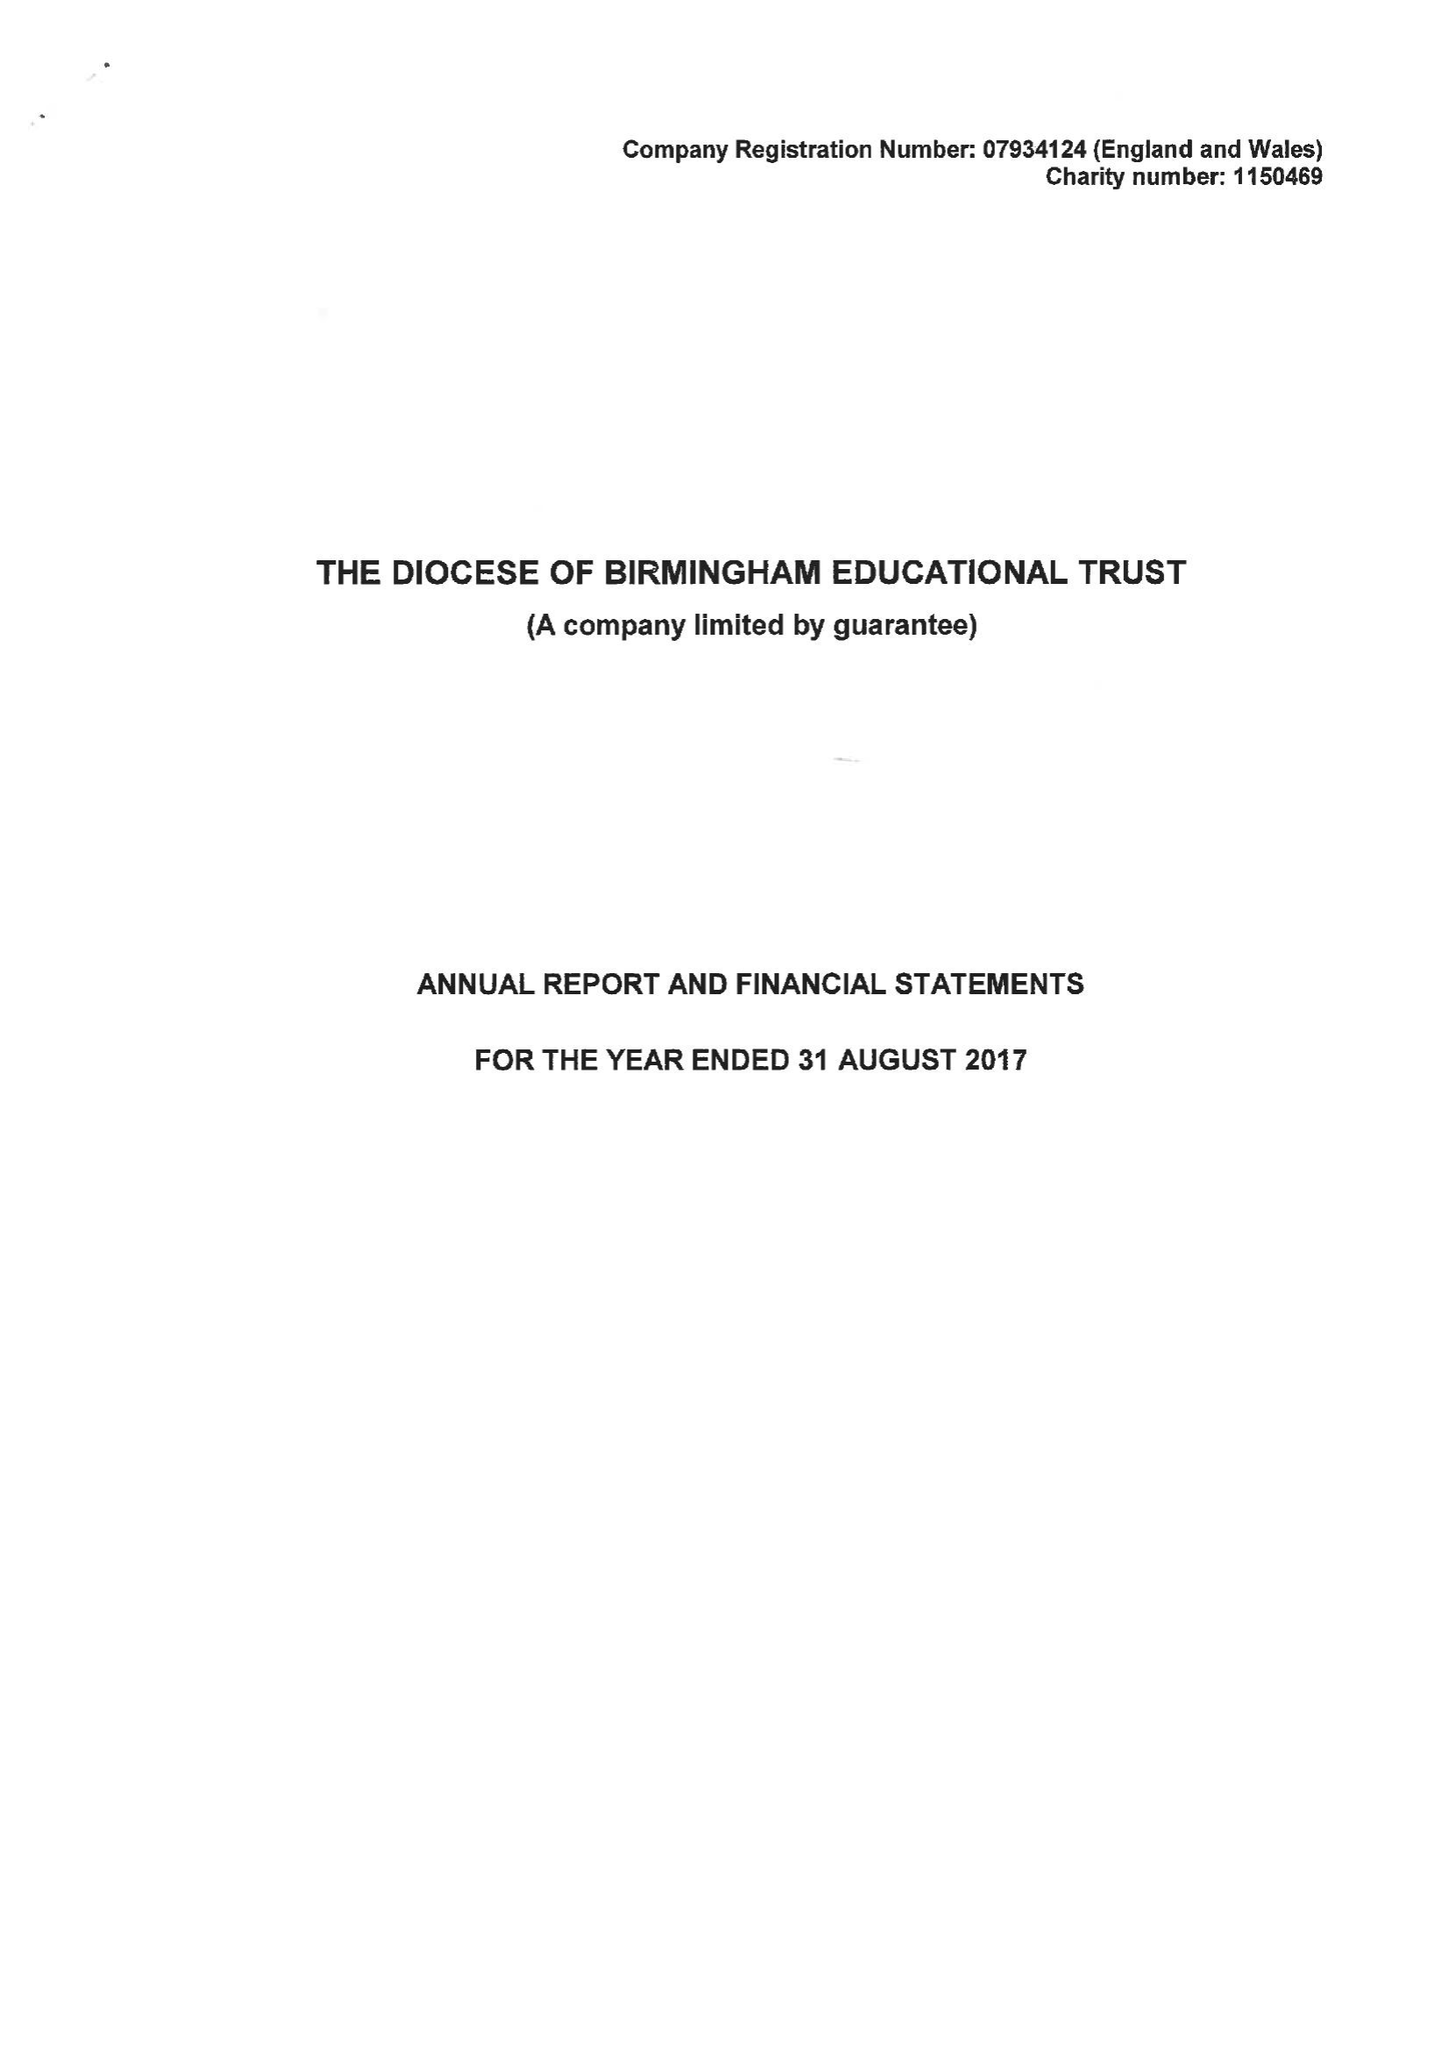What is the value for the charity_number?
Answer the question using a single word or phrase. 1150469 